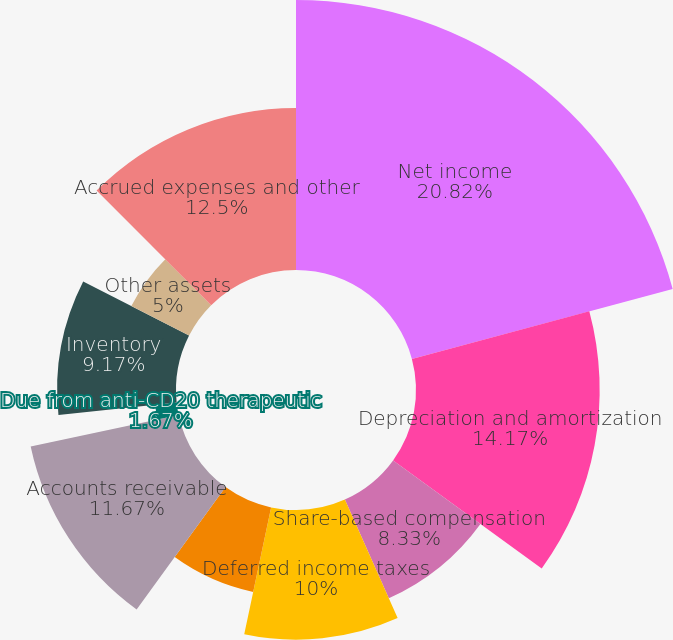Convert chart. <chart><loc_0><loc_0><loc_500><loc_500><pie_chart><fcel>Net income<fcel>Depreciation and amortization<fcel>Share-based compensation<fcel>Deferred income taxes<fcel>Other<fcel>Accounts receivable<fcel>Due from anti-CD20 therapeutic<fcel>Inventory<fcel>Other assets<fcel>Accrued expenses and other<nl><fcel>20.83%<fcel>14.17%<fcel>8.33%<fcel>10.0%<fcel>6.67%<fcel>11.67%<fcel>1.67%<fcel>9.17%<fcel>5.0%<fcel>12.5%<nl></chart> 